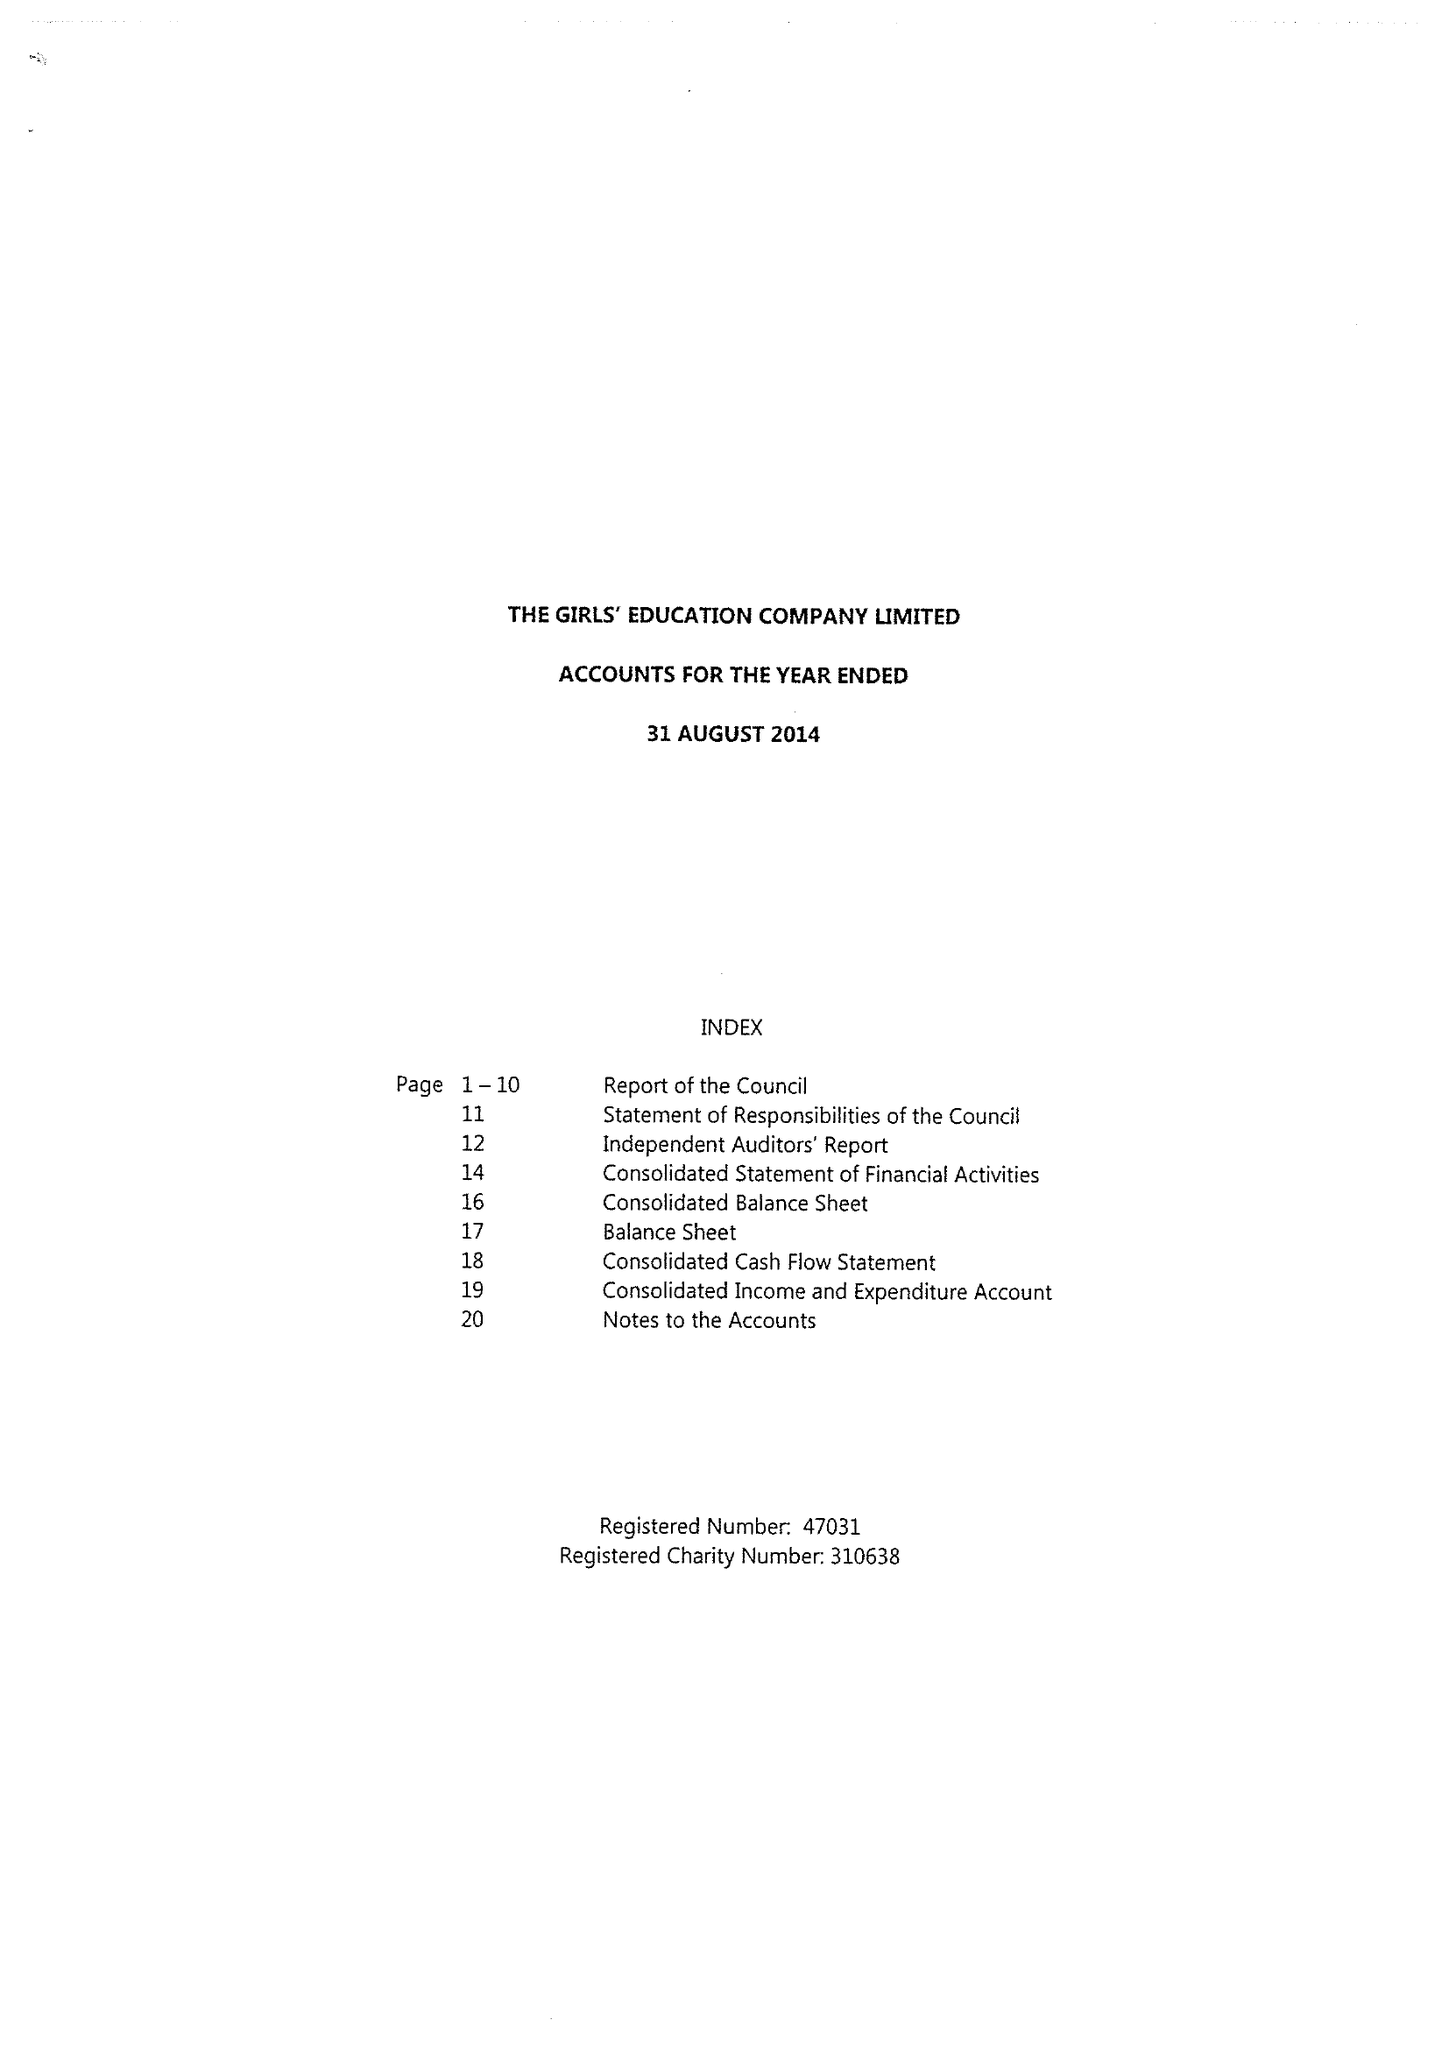What is the value for the spending_annually_in_british_pounds?
Answer the question using a single word or phrase. 18809201.00 